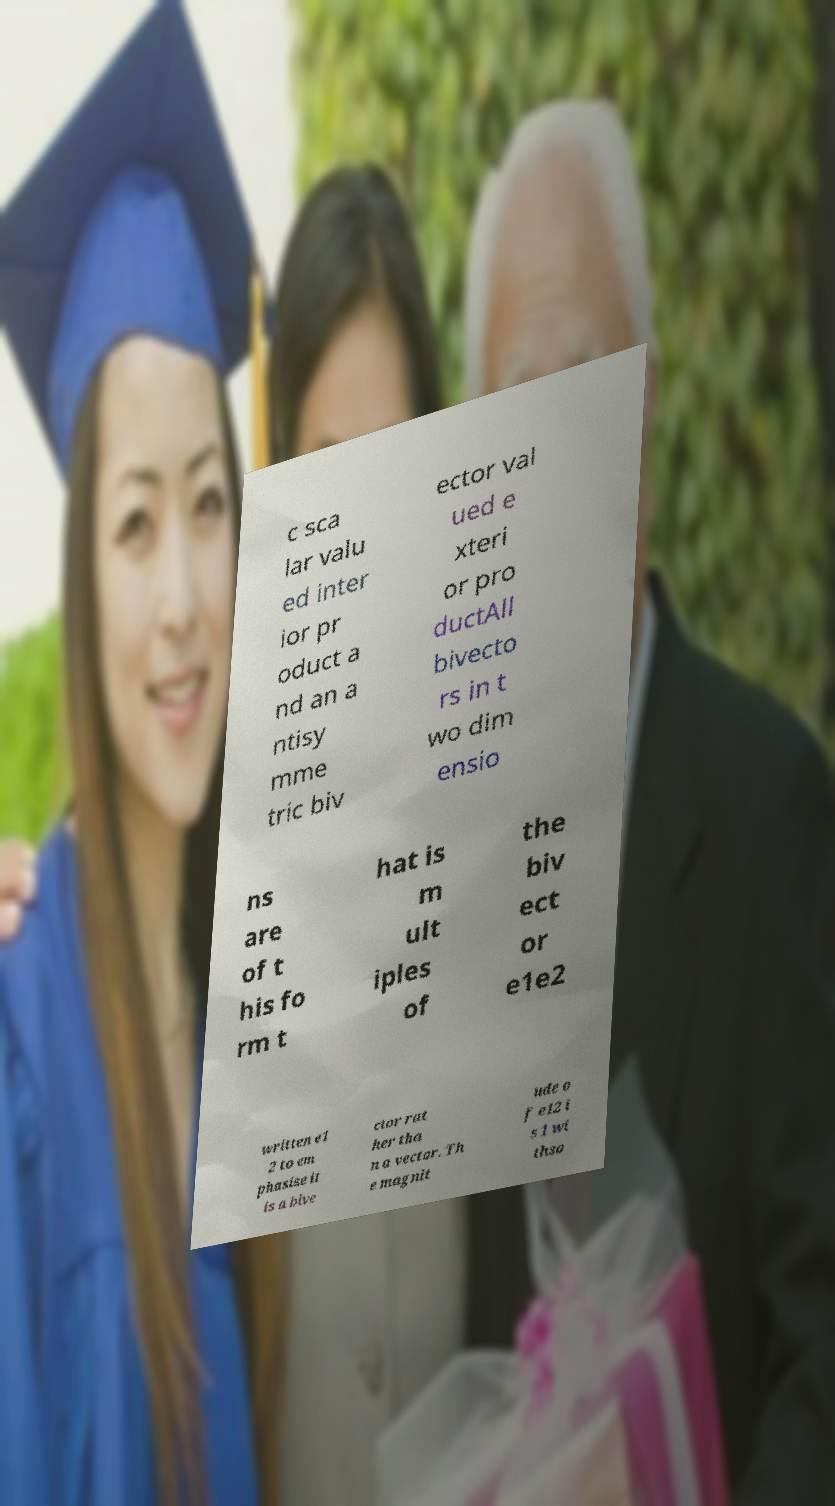Can you read and provide the text displayed in the image?This photo seems to have some interesting text. Can you extract and type it out for me? c sca lar valu ed inter ior pr oduct a nd an a ntisy mme tric biv ector val ued e xteri or pro ductAll bivecto rs in t wo dim ensio ns are of t his fo rm t hat is m ult iples of the biv ect or e1e2 written e1 2 to em phasise it is a bive ctor rat her tha n a vector. Th e magnit ude o f e12 i s 1 wi thso 